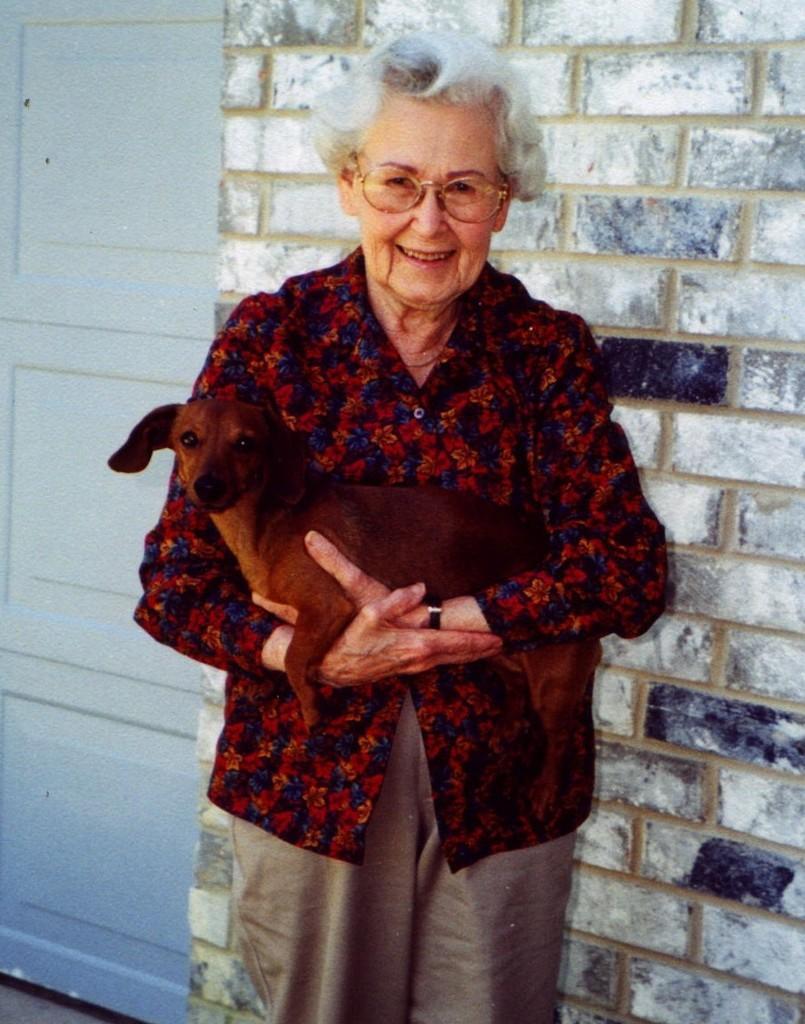Please provide a concise description of this image. This picture describes about standing woman she is laughing and she is holding a dog in the background we can see the wall and a door. 